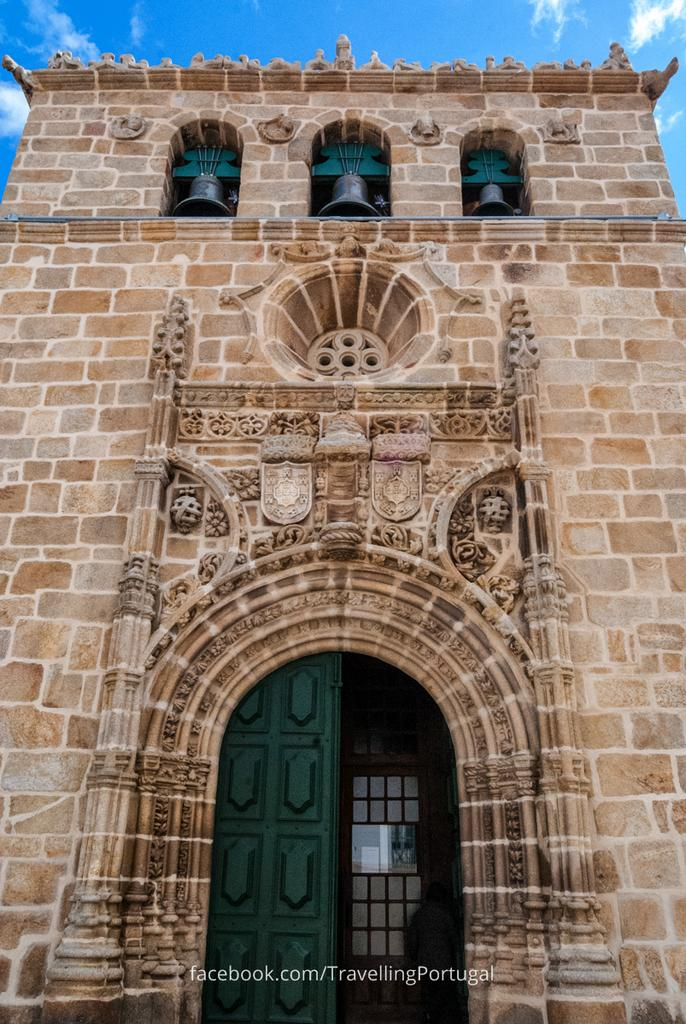What type of structure is visible in the image? There is a building in the image. What distinguishing feature does the building have? The building has three bells. Are there any architectural elements present in the building? Yes, the building has arches. What color is the door on the building? The door on the building is green. How would you describe the sky in the image? The sky is blue and cloudy in the image. What type of leather is being used to cover the building's knee in the image? There is no leather or knee present on the building in the image. 